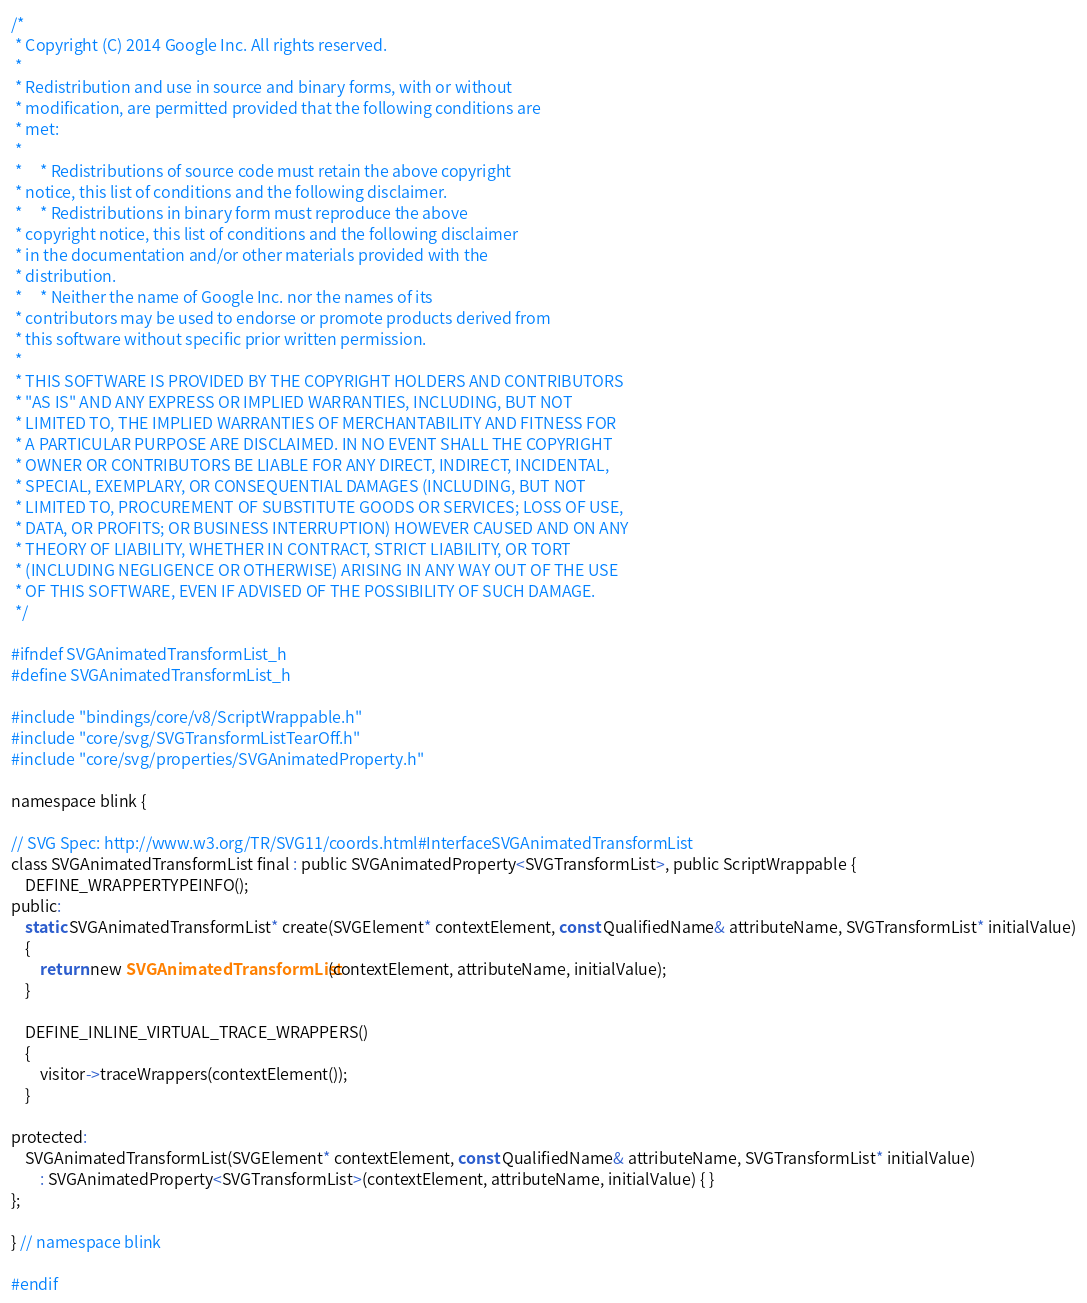Convert code to text. <code><loc_0><loc_0><loc_500><loc_500><_C_>/*
 * Copyright (C) 2014 Google Inc. All rights reserved.
 *
 * Redistribution and use in source and binary forms, with or without
 * modification, are permitted provided that the following conditions are
 * met:
 *
 *     * Redistributions of source code must retain the above copyright
 * notice, this list of conditions and the following disclaimer.
 *     * Redistributions in binary form must reproduce the above
 * copyright notice, this list of conditions and the following disclaimer
 * in the documentation and/or other materials provided with the
 * distribution.
 *     * Neither the name of Google Inc. nor the names of its
 * contributors may be used to endorse or promote products derived from
 * this software without specific prior written permission.
 *
 * THIS SOFTWARE IS PROVIDED BY THE COPYRIGHT HOLDERS AND CONTRIBUTORS
 * "AS IS" AND ANY EXPRESS OR IMPLIED WARRANTIES, INCLUDING, BUT NOT
 * LIMITED TO, THE IMPLIED WARRANTIES OF MERCHANTABILITY AND FITNESS FOR
 * A PARTICULAR PURPOSE ARE DISCLAIMED. IN NO EVENT SHALL THE COPYRIGHT
 * OWNER OR CONTRIBUTORS BE LIABLE FOR ANY DIRECT, INDIRECT, INCIDENTAL,
 * SPECIAL, EXEMPLARY, OR CONSEQUENTIAL DAMAGES (INCLUDING, BUT NOT
 * LIMITED TO, PROCUREMENT OF SUBSTITUTE GOODS OR SERVICES; LOSS OF USE,
 * DATA, OR PROFITS; OR BUSINESS INTERRUPTION) HOWEVER CAUSED AND ON ANY
 * THEORY OF LIABILITY, WHETHER IN CONTRACT, STRICT LIABILITY, OR TORT
 * (INCLUDING NEGLIGENCE OR OTHERWISE) ARISING IN ANY WAY OUT OF THE USE
 * OF THIS SOFTWARE, EVEN IF ADVISED OF THE POSSIBILITY OF SUCH DAMAGE.
 */

#ifndef SVGAnimatedTransformList_h
#define SVGAnimatedTransformList_h

#include "bindings/core/v8/ScriptWrappable.h"
#include "core/svg/SVGTransformListTearOff.h"
#include "core/svg/properties/SVGAnimatedProperty.h"

namespace blink {

// SVG Spec: http://www.w3.org/TR/SVG11/coords.html#InterfaceSVGAnimatedTransformList
class SVGAnimatedTransformList final : public SVGAnimatedProperty<SVGTransformList>, public ScriptWrappable {
    DEFINE_WRAPPERTYPEINFO();
public:
    static SVGAnimatedTransformList* create(SVGElement* contextElement, const QualifiedName& attributeName, SVGTransformList* initialValue)
    {
        return new SVGAnimatedTransformList(contextElement, attributeName, initialValue);
    }

    DEFINE_INLINE_VIRTUAL_TRACE_WRAPPERS()
    {
        visitor->traceWrappers(contextElement());
    }

protected:
    SVGAnimatedTransformList(SVGElement* contextElement, const QualifiedName& attributeName, SVGTransformList* initialValue)
        : SVGAnimatedProperty<SVGTransformList>(contextElement, attributeName, initialValue) { }
};

} // namespace blink

#endif
</code> 